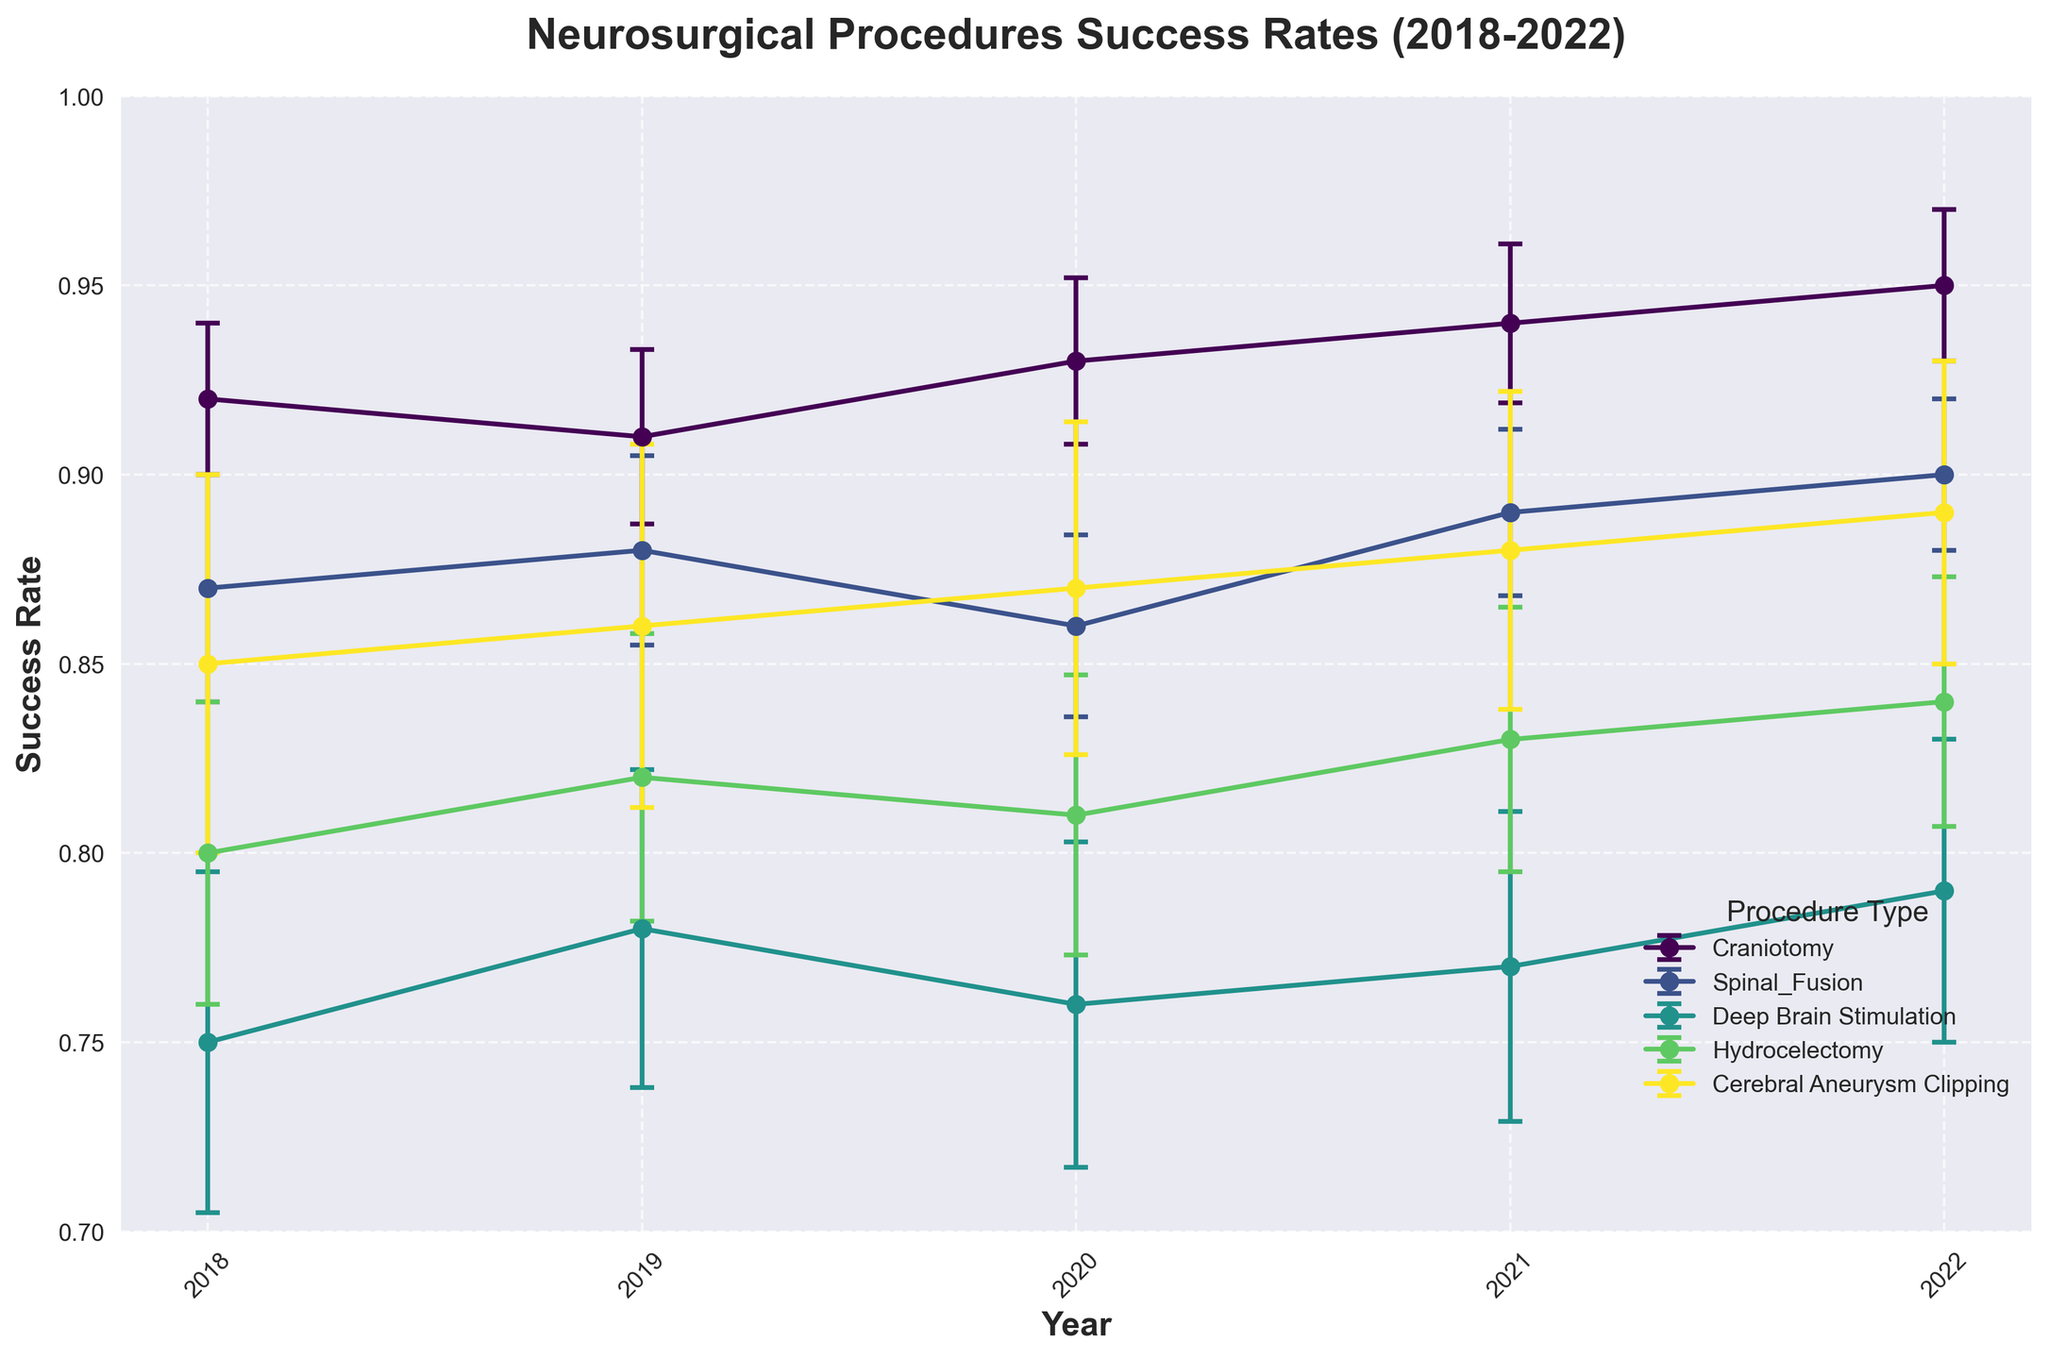What is the title of the figure? The title is usually located at the top of the figure and it helps in understanding the subject of the plot.
Answer: Neurosurgical Procedures Success Rates (2018-2022) What are the labels on the x-axis and y-axis? The x-axis label is usually positioned horizontally along the bottom of the graph, while the y-axis label is vertically aligned on the left side of the graph.
Answer: Year, Success Rate Which procedure has the highest success rate in 2022? Look for the data points corresponding to 2022 and identify which procedure reaches the highest on the y-axis.
Answer: Craniotomy How many types of procedures are represented in the plot? Count the different lines in the legend since each line represents a distinct procedure type.
Answer: 5 What was the success rate of Deep Brain Stimulation in 2020? Locate the data point for Deep Brain Stimulation in the year 2020 and check its value on the y-axis.
Answer: 0.76 Which procedure shows the greatest increase in success rate from 2018 to 2022? Compare the success rate for each procedure in 2018 and 2022, and calculate the difference for each to find the largest increase.
Answer: Craniotomy Is there any procedure whose success rate decreased between 2019 and 2020? Look at the success rates for each procedure for 2019 and 2020, and identify if any have a lower value in 2020 compared to 2019.
Answer: Spinal Fusion Which procedures have an error margin greater than 0.04 at any point between 2018 and 2022? Identify all data points where the error bars exceed 0.04.
Answer: Deep Brain Stimulation, Cerebral Aneurysm Clipping Which procedure had the most consistent success rate over the years 2018 to 2022? Look for the line with the smallest variation (i.e., the flattest curve) in success rate across the years.
Answer: Craniotomy How did the success rate of Hydrocelectomy change from 2018 to 2021? Track the changes in the success rate for Hydrocelectomy from 2018 to 2021 year by year to understand its trend.
Answer: Increased from 0.80 to 0.83 